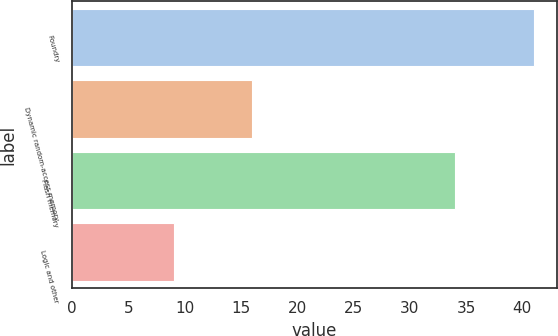Convert chart. <chart><loc_0><loc_0><loc_500><loc_500><bar_chart><fcel>Foundry<fcel>Dynamic random-access memory<fcel>Flash memory<fcel>Logic and other<nl><fcel>41<fcel>16<fcel>34<fcel>9<nl></chart> 